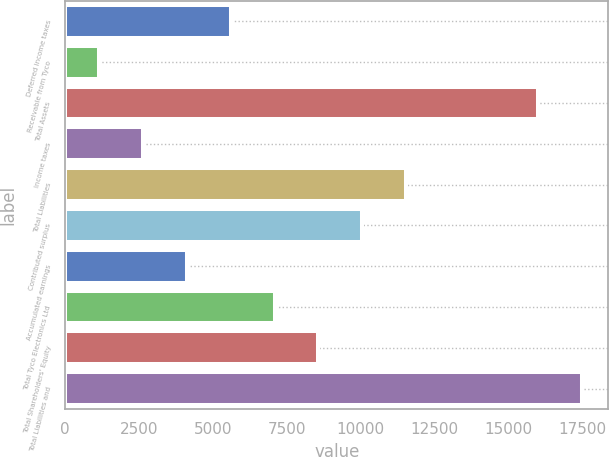Convert chart to OTSL. <chart><loc_0><loc_0><loc_500><loc_500><bar_chart><fcel>Deferred income taxes<fcel>Receivable from Tyco<fcel>Total Assets<fcel>Income taxes<fcel>Total Liabilities<fcel>Contributed surplus<fcel>Accumulated earnings<fcel>Total Tyco Electronics Ltd<fcel>Total Shareholders' Equity<fcel>Total Liabilities and<nl><fcel>5596.4<fcel>1130<fcel>16018<fcel>2618.8<fcel>11551.6<fcel>10062.8<fcel>4107.6<fcel>7085.2<fcel>8574<fcel>17506.8<nl></chart> 